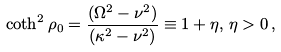<formula> <loc_0><loc_0><loc_500><loc_500>\coth ^ { 2 } \rho _ { 0 } = { \frac { ( \Omega ^ { 2 } - \nu ^ { 2 } ) } { ( \kappa ^ { 2 } - \nu ^ { 2 } ) } } \equiv 1 + \eta , \, \eta > 0 \, ,</formula> 